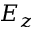<formula> <loc_0><loc_0><loc_500><loc_500>E _ { z }</formula> 